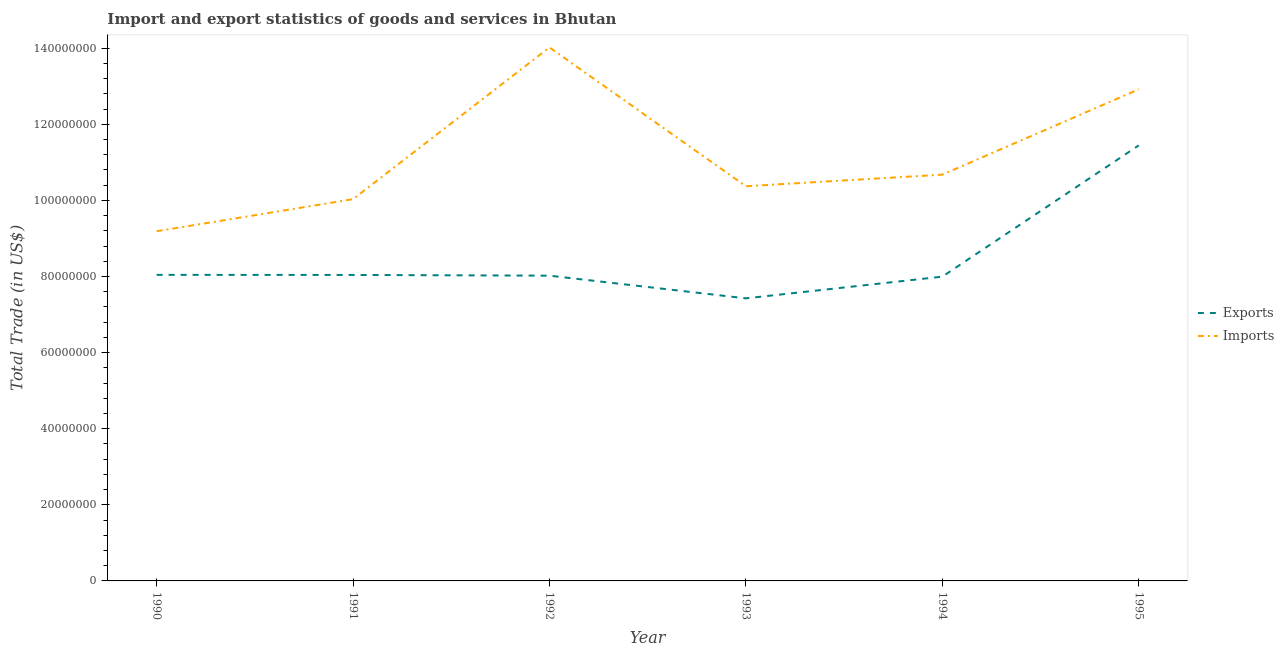How many different coloured lines are there?
Make the answer very short. 2. Does the line corresponding to imports of goods and services intersect with the line corresponding to export of goods and services?
Offer a terse response. No. Is the number of lines equal to the number of legend labels?
Keep it short and to the point. Yes. What is the imports of goods and services in 1991?
Make the answer very short. 1.00e+08. Across all years, what is the maximum export of goods and services?
Your answer should be very brief. 1.14e+08. Across all years, what is the minimum export of goods and services?
Offer a terse response. 7.43e+07. What is the total imports of goods and services in the graph?
Your answer should be compact. 6.72e+08. What is the difference between the imports of goods and services in 1990 and that in 1995?
Keep it short and to the point. -3.73e+07. What is the difference between the export of goods and services in 1994 and the imports of goods and services in 1990?
Give a very brief answer. -1.19e+07. What is the average export of goods and services per year?
Offer a very short reply. 8.50e+07. In the year 1990, what is the difference between the export of goods and services and imports of goods and services?
Make the answer very short. -1.15e+07. What is the ratio of the export of goods and services in 1990 to that in 1994?
Ensure brevity in your answer.  1.01. Is the export of goods and services in 1990 less than that in 1991?
Your answer should be compact. No. Is the difference between the export of goods and services in 1990 and 1995 greater than the difference between the imports of goods and services in 1990 and 1995?
Give a very brief answer. Yes. What is the difference between the highest and the second highest imports of goods and services?
Keep it short and to the point. 1.10e+07. What is the difference between the highest and the lowest imports of goods and services?
Offer a terse response. 4.83e+07. Is the sum of the export of goods and services in 1990 and 1995 greater than the maximum imports of goods and services across all years?
Your response must be concise. Yes. Is the imports of goods and services strictly less than the export of goods and services over the years?
Offer a terse response. No. How many years are there in the graph?
Offer a terse response. 6. How many legend labels are there?
Provide a succinct answer. 2. How are the legend labels stacked?
Keep it short and to the point. Vertical. What is the title of the graph?
Ensure brevity in your answer.  Import and export statistics of goods and services in Bhutan. What is the label or title of the X-axis?
Your response must be concise. Year. What is the label or title of the Y-axis?
Keep it short and to the point. Total Trade (in US$). What is the Total Trade (in US$) in Exports in 1990?
Provide a succinct answer. 8.04e+07. What is the Total Trade (in US$) in Imports in 1990?
Make the answer very short. 9.19e+07. What is the Total Trade (in US$) of Exports in 1991?
Offer a terse response. 8.04e+07. What is the Total Trade (in US$) of Imports in 1991?
Your answer should be compact. 1.00e+08. What is the Total Trade (in US$) in Exports in 1992?
Offer a very short reply. 8.02e+07. What is the Total Trade (in US$) of Imports in 1992?
Your response must be concise. 1.40e+08. What is the Total Trade (in US$) of Exports in 1993?
Provide a succinct answer. 7.43e+07. What is the Total Trade (in US$) of Imports in 1993?
Ensure brevity in your answer.  1.04e+08. What is the Total Trade (in US$) of Exports in 1994?
Keep it short and to the point. 8.00e+07. What is the Total Trade (in US$) in Imports in 1994?
Offer a very short reply. 1.07e+08. What is the Total Trade (in US$) of Exports in 1995?
Your response must be concise. 1.14e+08. What is the Total Trade (in US$) of Imports in 1995?
Keep it short and to the point. 1.29e+08. Across all years, what is the maximum Total Trade (in US$) of Exports?
Offer a very short reply. 1.14e+08. Across all years, what is the maximum Total Trade (in US$) of Imports?
Offer a very short reply. 1.40e+08. Across all years, what is the minimum Total Trade (in US$) in Exports?
Your answer should be compact. 7.43e+07. Across all years, what is the minimum Total Trade (in US$) in Imports?
Your answer should be very brief. 9.19e+07. What is the total Total Trade (in US$) in Exports in the graph?
Give a very brief answer. 5.10e+08. What is the total Total Trade (in US$) of Imports in the graph?
Give a very brief answer. 6.72e+08. What is the difference between the Total Trade (in US$) of Exports in 1990 and that in 1991?
Your answer should be very brief. 2.37e+04. What is the difference between the Total Trade (in US$) of Imports in 1990 and that in 1991?
Give a very brief answer. -8.43e+06. What is the difference between the Total Trade (in US$) in Exports in 1990 and that in 1992?
Make the answer very short. 2.14e+05. What is the difference between the Total Trade (in US$) of Imports in 1990 and that in 1992?
Offer a very short reply. -4.83e+07. What is the difference between the Total Trade (in US$) in Exports in 1990 and that in 1993?
Provide a short and direct response. 6.17e+06. What is the difference between the Total Trade (in US$) of Imports in 1990 and that in 1993?
Make the answer very short. -1.18e+07. What is the difference between the Total Trade (in US$) in Exports in 1990 and that in 1994?
Keep it short and to the point. 4.70e+05. What is the difference between the Total Trade (in US$) in Imports in 1990 and that in 1994?
Your answer should be very brief. -1.49e+07. What is the difference between the Total Trade (in US$) in Exports in 1990 and that in 1995?
Provide a short and direct response. -3.40e+07. What is the difference between the Total Trade (in US$) of Imports in 1990 and that in 1995?
Your response must be concise. -3.73e+07. What is the difference between the Total Trade (in US$) of Exports in 1991 and that in 1992?
Your response must be concise. 1.90e+05. What is the difference between the Total Trade (in US$) in Imports in 1991 and that in 1992?
Your response must be concise. -3.99e+07. What is the difference between the Total Trade (in US$) in Exports in 1991 and that in 1993?
Your response must be concise. 6.15e+06. What is the difference between the Total Trade (in US$) of Imports in 1991 and that in 1993?
Provide a short and direct response. -3.40e+06. What is the difference between the Total Trade (in US$) of Exports in 1991 and that in 1994?
Your response must be concise. 4.46e+05. What is the difference between the Total Trade (in US$) in Imports in 1991 and that in 1994?
Your answer should be very brief. -6.44e+06. What is the difference between the Total Trade (in US$) of Exports in 1991 and that in 1995?
Provide a succinct answer. -3.40e+07. What is the difference between the Total Trade (in US$) of Imports in 1991 and that in 1995?
Your response must be concise. -2.89e+07. What is the difference between the Total Trade (in US$) in Exports in 1992 and that in 1993?
Your response must be concise. 5.96e+06. What is the difference between the Total Trade (in US$) in Imports in 1992 and that in 1993?
Your response must be concise. 3.65e+07. What is the difference between the Total Trade (in US$) of Exports in 1992 and that in 1994?
Your response must be concise. 2.56e+05. What is the difference between the Total Trade (in US$) of Imports in 1992 and that in 1994?
Offer a terse response. 3.34e+07. What is the difference between the Total Trade (in US$) of Exports in 1992 and that in 1995?
Keep it short and to the point. -3.42e+07. What is the difference between the Total Trade (in US$) of Imports in 1992 and that in 1995?
Provide a succinct answer. 1.10e+07. What is the difference between the Total Trade (in US$) in Exports in 1993 and that in 1994?
Offer a terse response. -5.70e+06. What is the difference between the Total Trade (in US$) in Imports in 1993 and that in 1994?
Your answer should be compact. -3.04e+06. What is the difference between the Total Trade (in US$) of Exports in 1993 and that in 1995?
Your answer should be very brief. -4.02e+07. What is the difference between the Total Trade (in US$) of Imports in 1993 and that in 1995?
Offer a terse response. -2.55e+07. What is the difference between the Total Trade (in US$) in Exports in 1994 and that in 1995?
Make the answer very short. -3.45e+07. What is the difference between the Total Trade (in US$) in Imports in 1994 and that in 1995?
Keep it short and to the point. -2.24e+07. What is the difference between the Total Trade (in US$) of Exports in 1990 and the Total Trade (in US$) of Imports in 1991?
Offer a terse response. -1.99e+07. What is the difference between the Total Trade (in US$) of Exports in 1990 and the Total Trade (in US$) of Imports in 1992?
Your answer should be very brief. -5.98e+07. What is the difference between the Total Trade (in US$) in Exports in 1990 and the Total Trade (in US$) in Imports in 1993?
Offer a very short reply. -2.33e+07. What is the difference between the Total Trade (in US$) of Exports in 1990 and the Total Trade (in US$) of Imports in 1994?
Keep it short and to the point. -2.63e+07. What is the difference between the Total Trade (in US$) in Exports in 1990 and the Total Trade (in US$) in Imports in 1995?
Give a very brief answer. -4.88e+07. What is the difference between the Total Trade (in US$) in Exports in 1991 and the Total Trade (in US$) in Imports in 1992?
Provide a succinct answer. -5.98e+07. What is the difference between the Total Trade (in US$) of Exports in 1991 and the Total Trade (in US$) of Imports in 1993?
Ensure brevity in your answer.  -2.33e+07. What is the difference between the Total Trade (in US$) of Exports in 1991 and the Total Trade (in US$) of Imports in 1994?
Provide a succinct answer. -2.64e+07. What is the difference between the Total Trade (in US$) in Exports in 1991 and the Total Trade (in US$) in Imports in 1995?
Ensure brevity in your answer.  -4.88e+07. What is the difference between the Total Trade (in US$) in Exports in 1992 and the Total Trade (in US$) in Imports in 1993?
Your answer should be compact. -2.35e+07. What is the difference between the Total Trade (in US$) in Exports in 1992 and the Total Trade (in US$) in Imports in 1994?
Make the answer very short. -2.65e+07. What is the difference between the Total Trade (in US$) of Exports in 1992 and the Total Trade (in US$) of Imports in 1995?
Keep it short and to the point. -4.90e+07. What is the difference between the Total Trade (in US$) in Exports in 1993 and the Total Trade (in US$) in Imports in 1994?
Make the answer very short. -3.25e+07. What is the difference between the Total Trade (in US$) in Exports in 1993 and the Total Trade (in US$) in Imports in 1995?
Your answer should be compact. -5.49e+07. What is the difference between the Total Trade (in US$) of Exports in 1994 and the Total Trade (in US$) of Imports in 1995?
Keep it short and to the point. -4.92e+07. What is the average Total Trade (in US$) of Exports per year?
Your response must be concise. 8.50e+07. What is the average Total Trade (in US$) of Imports per year?
Provide a succinct answer. 1.12e+08. In the year 1990, what is the difference between the Total Trade (in US$) in Exports and Total Trade (in US$) in Imports?
Offer a terse response. -1.15e+07. In the year 1991, what is the difference between the Total Trade (in US$) in Exports and Total Trade (in US$) in Imports?
Offer a very short reply. -1.99e+07. In the year 1992, what is the difference between the Total Trade (in US$) of Exports and Total Trade (in US$) of Imports?
Provide a short and direct response. -6.00e+07. In the year 1993, what is the difference between the Total Trade (in US$) of Exports and Total Trade (in US$) of Imports?
Your response must be concise. -2.95e+07. In the year 1994, what is the difference between the Total Trade (in US$) of Exports and Total Trade (in US$) of Imports?
Keep it short and to the point. -2.68e+07. In the year 1995, what is the difference between the Total Trade (in US$) of Exports and Total Trade (in US$) of Imports?
Offer a terse response. -1.47e+07. What is the ratio of the Total Trade (in US$) in Exports in 1990 to that in 1991?
Provide a short and direct response. 1. What is the ratio of the Total Trade (in US$) in Imports in 1990 to that in 1991?
Ensure brevity in your answer.  0.92. What is the ratio of the Total Trade (in US$) of Exports in 1990 to that in 1992?
Ensure brevity in your answer.  1. What is the ratio of the Total Trade (in US$) in Imports in 1990 to that in 1992?
Your answer should be compact. 0.66. What is the ratio of the Total Trade (in US$) in Exports in 1990 to that in 1993?
Make the answer very short. 1.08. What is the ratio of the Total Trade (in US$) of Imports in 1990 to that in 1993?
Provide a succinct answer. 0.89. What is the ratio of the Total Trade (in US$) of Exports in 1990 to that in 1994?
Give a very brief answer. 1.01. What is the ratio of the Total Trade (in US$) in Imports in 1990 to that in 1994?
Offer a very short reply. 0.86. What is the ratio of the Total Trade (in US$) in Exports in 1990 to that in 1995?
Ensure brevity in your answer.  0.7. What is the ratio of the Total Trade (in US$) of Imports in 1990 to that in 1995?
Keep it short and to the point. 0.71. What is the ratio of the Total Trade (in US$) of Exports in 1991 to that in 1992?
Give a very brief answer. 1. What is the ratio of the Total Trade (in US$) in Imports in 1991 to that in 1992?
Give a very brief answer. 0.72. What is the ratio of the Total Trade (in US$) in Exports in 1991 to that in 1993?
Give a very brief answer. 1.08. What is the ratio of the Total Trade (in US$) of Imports in 1991 to that in 1993?
Offer a terse response. 0.97. What is the ratio of the Total Trade (in US$) of Exports in 1991 to that in 1994?
Your answer should be compact. 1.01. What is the ratio of the Total Trade (in US$) in Imports in 1991 to that in 1994?
Give a very brief answer. 0.94. What is the ratio of the Total Trade (in US$) of Exports in 1991 to that in 1995?
Make the answer very short. 0.7. What is the ratio of the Total Trade (in US$) in Imports in 1991 to that in 1995?
Your answer should be compact. 0.78. What is the ratio of the Total Trade (in US$) in Exports in 1992 to that in 1993?
Provide a succinct answer. 1.08. What is the ratio of the Total Trade (in US$) in Imports in 1992 to that in 1993?
Keep it short and to the point. 1.35. What is the ratio of the Total Trade (in US$) in Imports in 1992 to that in 1994?
Provide a short and direct response. 1.31. What is the ratio of the Total Trade (in US$) of Exports in 1992 to that in 1995?
Offer a very short reply. 0.7. What is the ratio of the Total Trade (in US$) in Imports in 1992 to that in 1995?
Provide a short and direct response. 1.09. What is the ratio of the Total Trade (in US$) in Exports in 1993 to that in 1994?
Ensure brevity in your answer.  0.93. What is the ratio of the Total Trade (in US$) of Imports in 1993 to that in 1994?
Give a very brief answer. 0.97. What is the ratio of the Total Trade (in US$) of Exports in 1993 to that in 1995?
Give a very brief answer. 0.65. What is the ratio of the Total Trade (in US$) of Imports in 1993 to that in 1995?
Provide a succinct answer. 0.8. What is the ratio of the Total Trade (in US$) in Exports in 1994 to that in 1995?
Your answer should be very brief. 0.7. What is the ratio of the Total Trade (in US$) in Imports in 1994 to that in 1995?
Your answer should be compact. 0.83. What is the difference between the highest and the second highest Total Trade (in US$) of Exports?
Your response must be concise. 3.40e+07. What is the difference between the highest and the second highest Total Trade (in US$) in Imports?
Keep it short and to the point. 1.10e+07. What is the difference between the highest and the lowest Total Trade (in US$) in Exports?
Keep it short and to the point. 4.02e+07. What is the difference between the highest and the lowest Total Trade (in US$) of Imports?
Provide a short and direct response. 4.83e+07. 